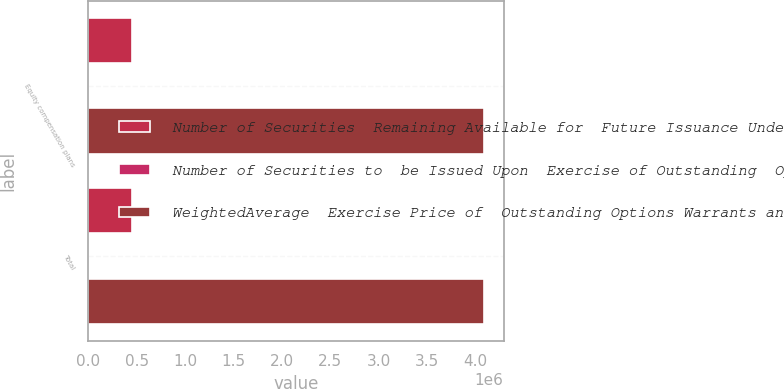Convert chart to OTSL. <chart><loc_0><loc_0><loc_500><loc_500><stacked_bar_chart><ecel><fcel>Equity compensation plans<fcel>Total<nl><fcel>Number of Securities  Remaining Available for  Future Issuance Under  Equity Compensation  Plans Excluding  Securities Reflected in Column a<fcel>448859<fcel>448859<nl><fcel>Number of Securities to  be Issued Upon  Exercise of Outstanding  Options Warrants and  Rights 1 a<fcel>0<fcel>0<nl><fcel>WeightedAverage  Exercise Price of  Outstanding Options Warrants and Rights<fcel>4.08759e+06<fcel>4.08759e+06<nl></chart> 